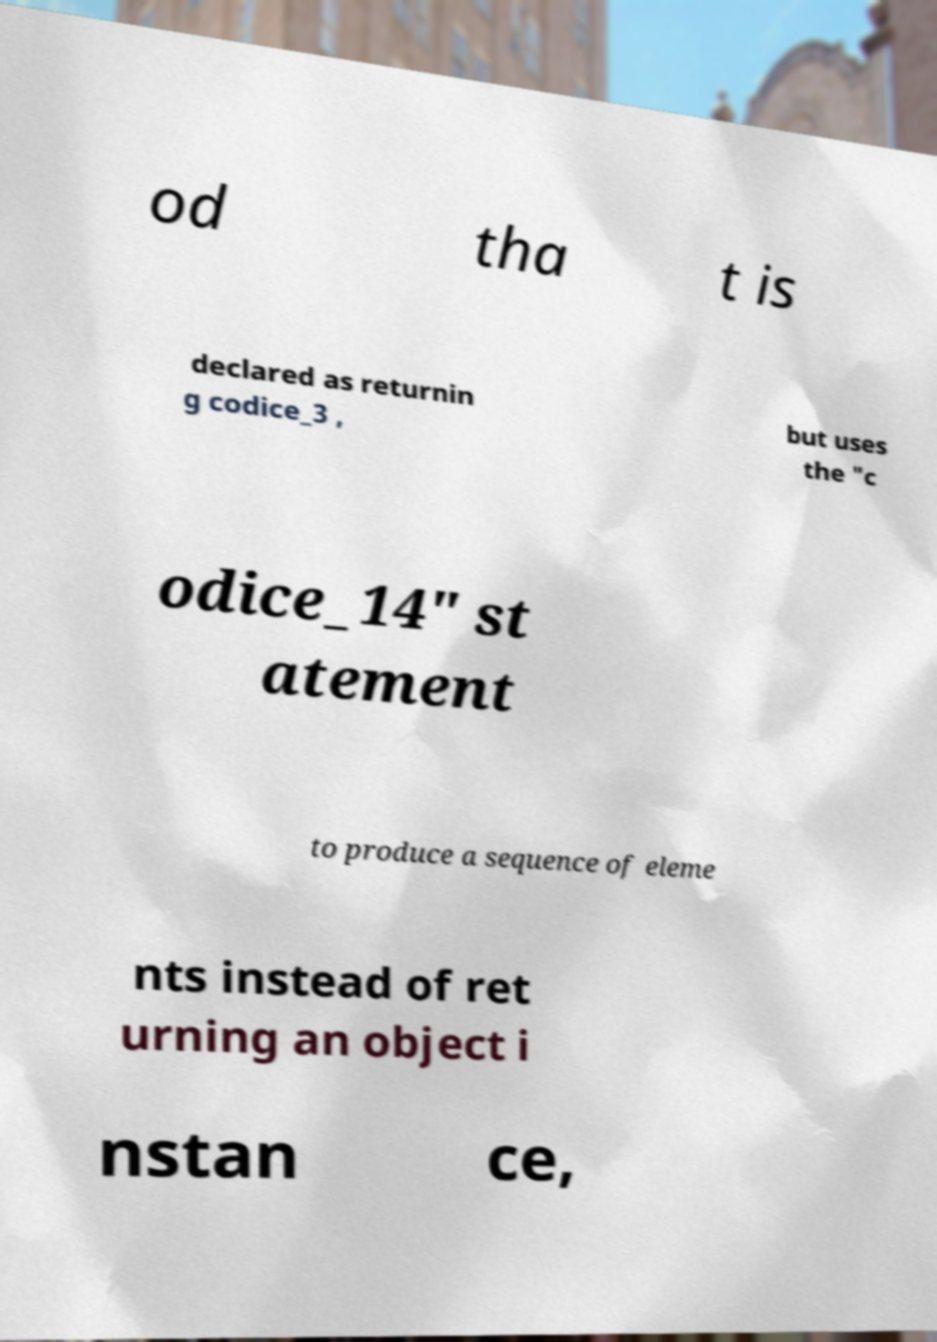Please read and relay the text visible in this image. What does it say? od tha t is declared as returnin g codice_3 , but uses the "c odice_14" st atement to produce a sequence of eleme nts instead of ret urning an object i nstan ce, 